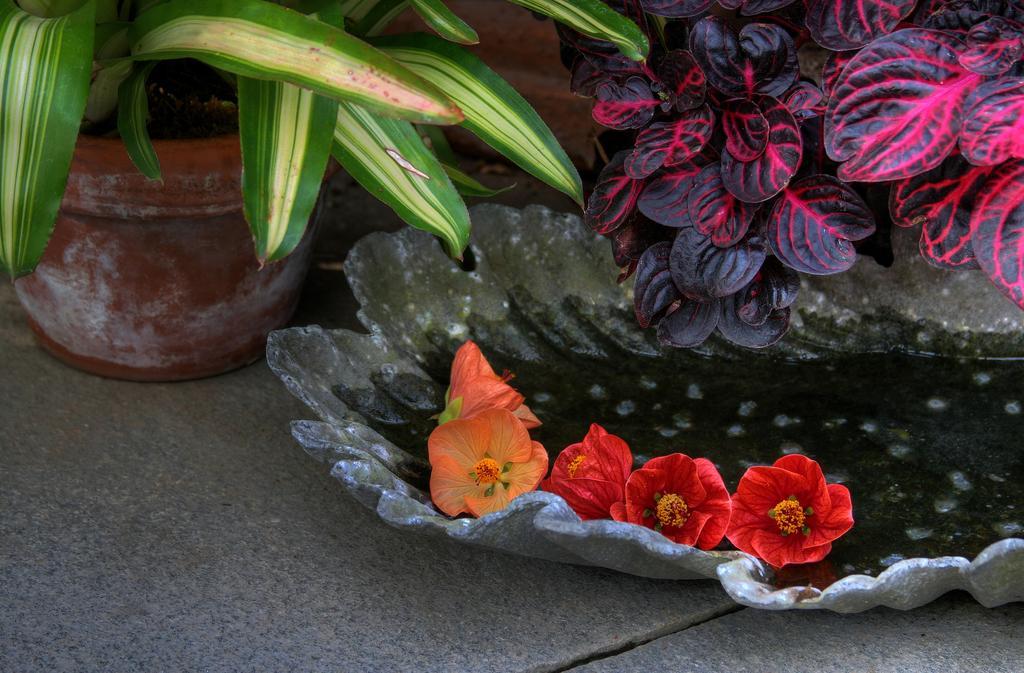Please provide a concise description of this image. In the foreground of this picture we can see the flowers and some amount of water in an object and we can see the leaves and the potted plant and we can see some other objects and the ground. 